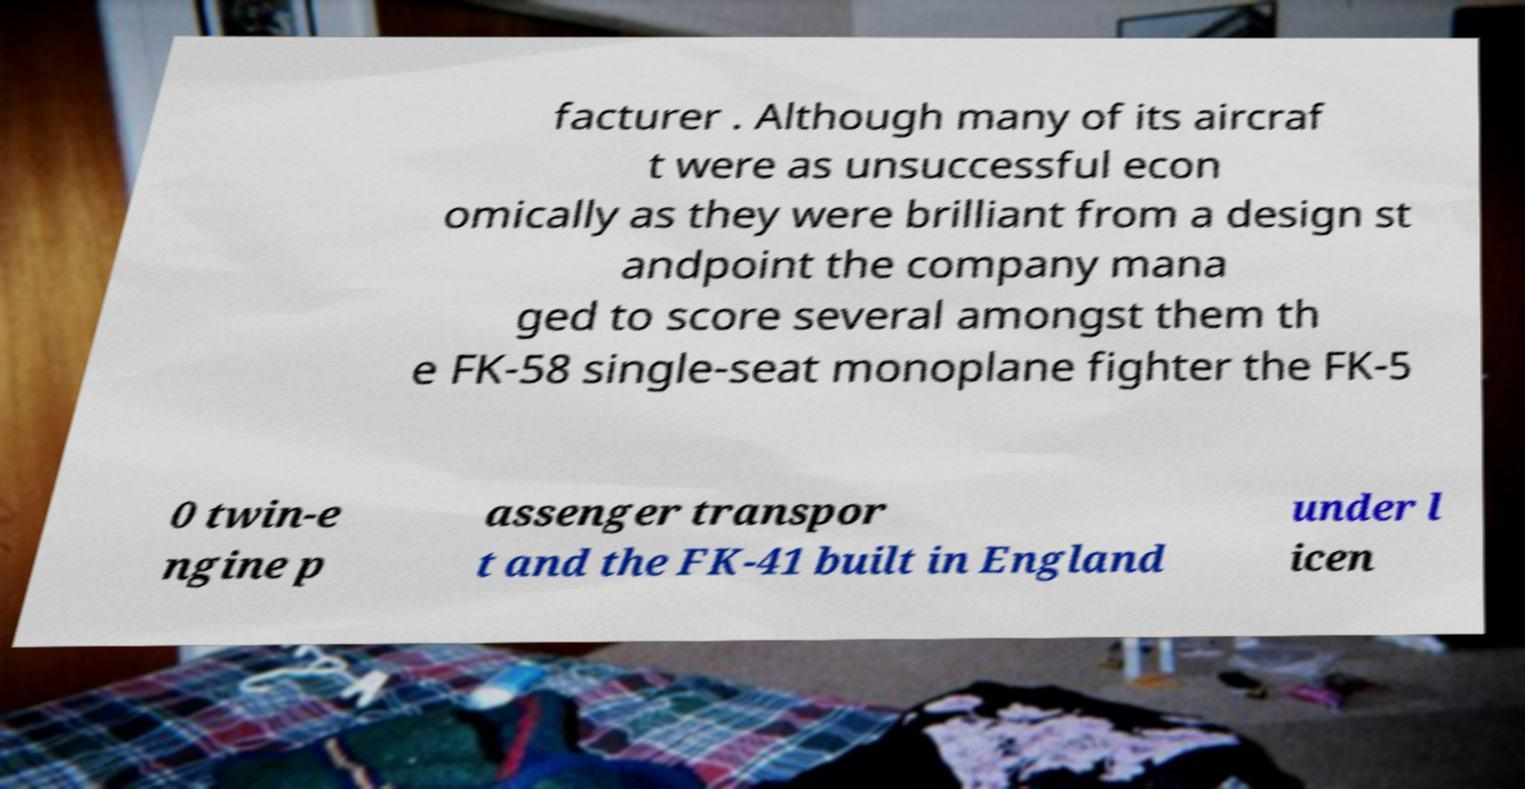For documentation purposes, I need the text within this image transcribed. Could you provide that? facturer . Although many of its aircraf t were as unsuccessful econ omically as they were brilliant from a design st andpoint the company mana ged to score several amongst them th e FK-58 single-seat monoplane fighter the FK-5 0 twin-e ngine p assenger transpor t and the FK-41 built in England under l icen 